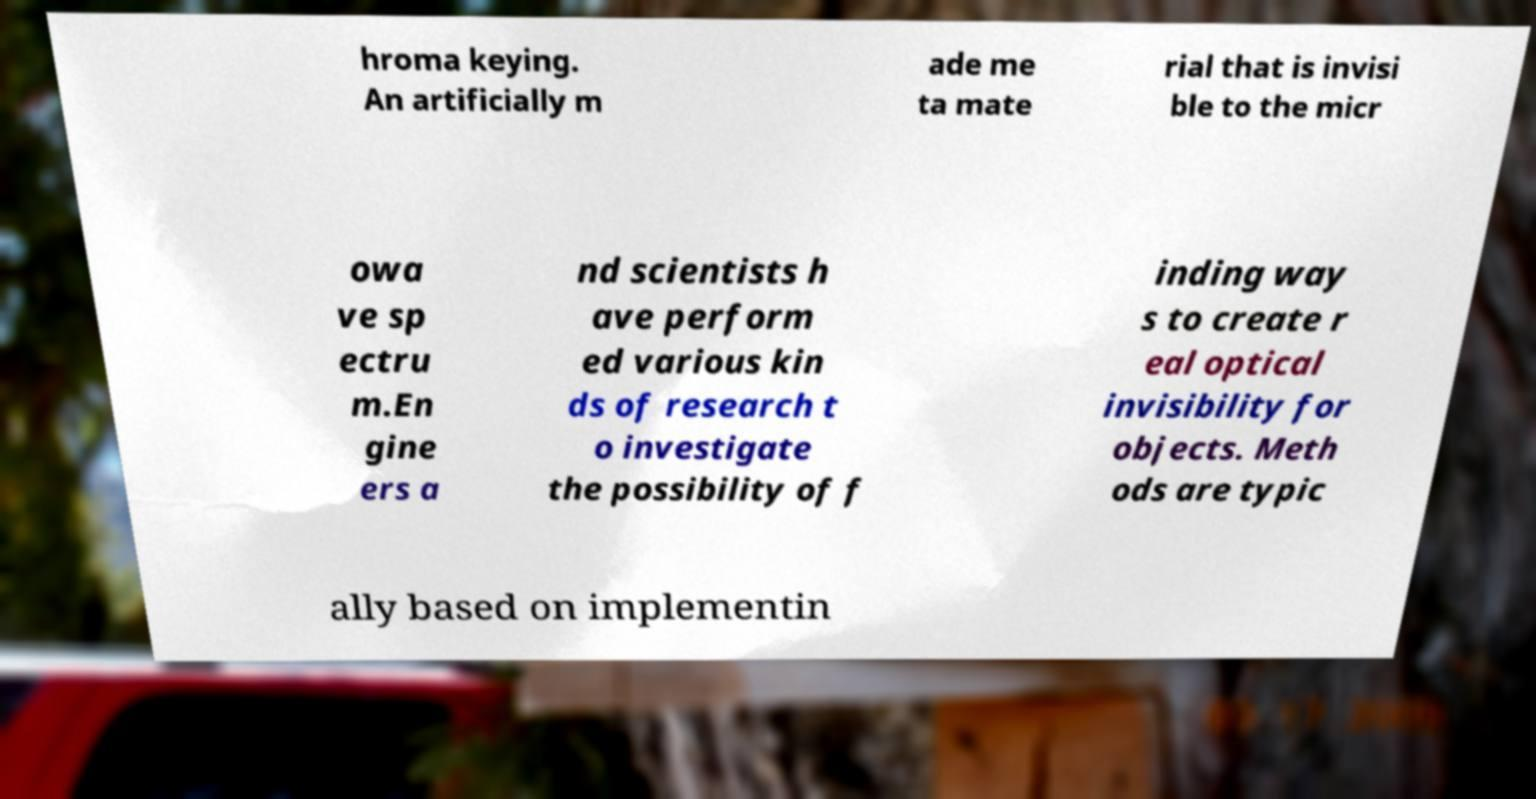I need the written content from this picture converted into text. Can you do that? hroma keying. An artificially m ade me ta mate rial that is invisi ble to the micr owa ve sp ectru m.En gine ers a nd scientists h ave perform ed various kin ds of research t o investigate the possibility of f inding way s to create r eal optical invisibility for objects. Meth ods are typic ally based on implementin 